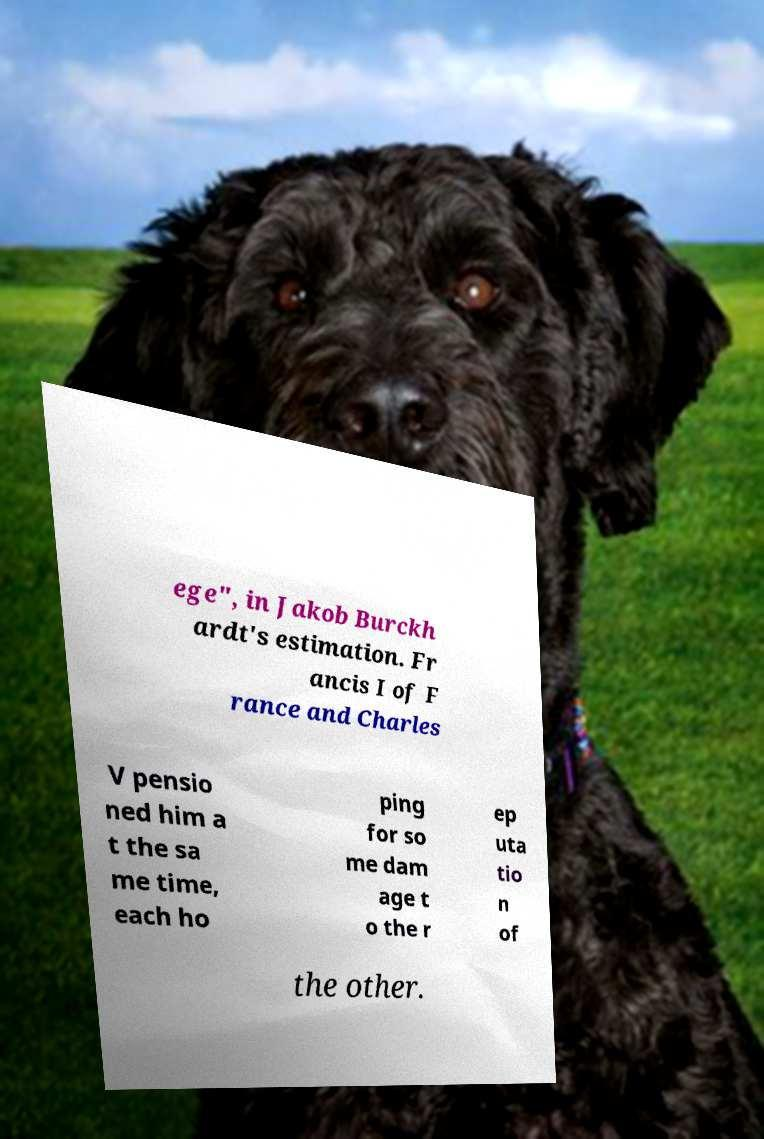Please read and relay the text visible in this image. What does it say? ege", in Jakob Burckh ardt's estimation. Fr ancis I of F rance and Charles V pensio ned him a t the sa me time, each ho ping for so me dam age t o the r ep uta tio n of the other. 